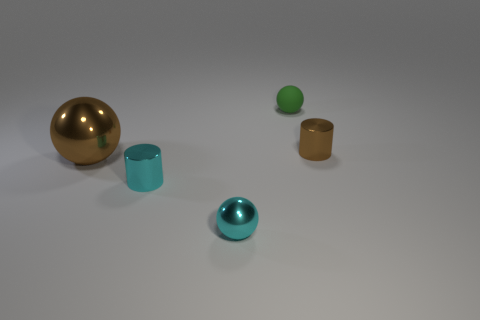Are there any other things that have the same color as the small matte object? Yes, the small green matte object appears to have a similar color to the larger green spherical item in the background. Both share a muted green hue, which distinguishes them from the other items with different colors in the image. 